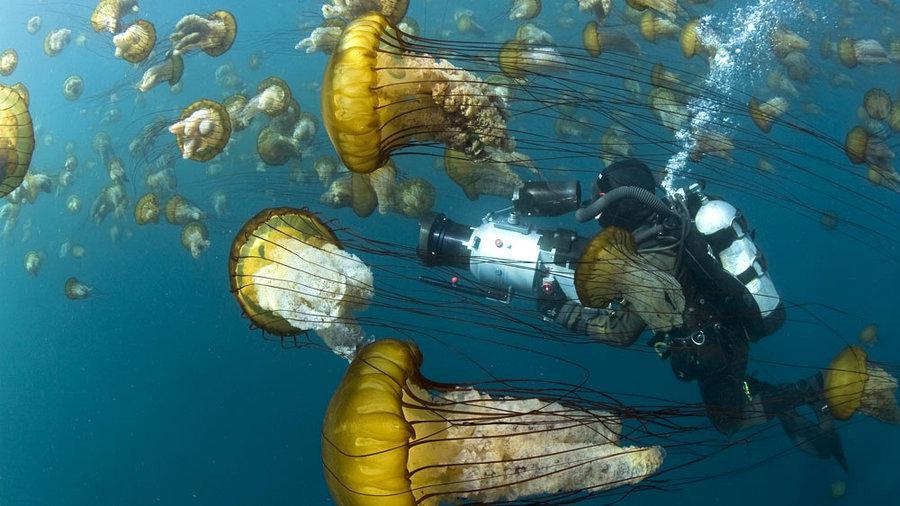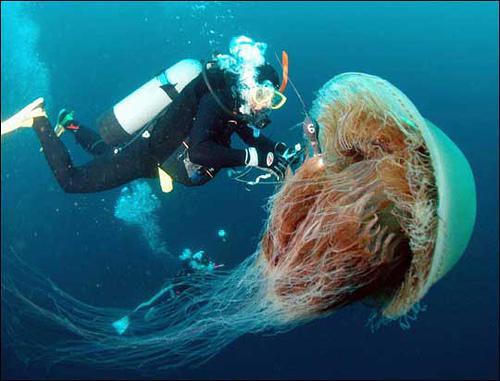The first image is the image on the left, the second image is the image on the right. Assess this claim about the two images: "Both images contain a single jellyfish.". Correct or not? Answer yes or no. No. 